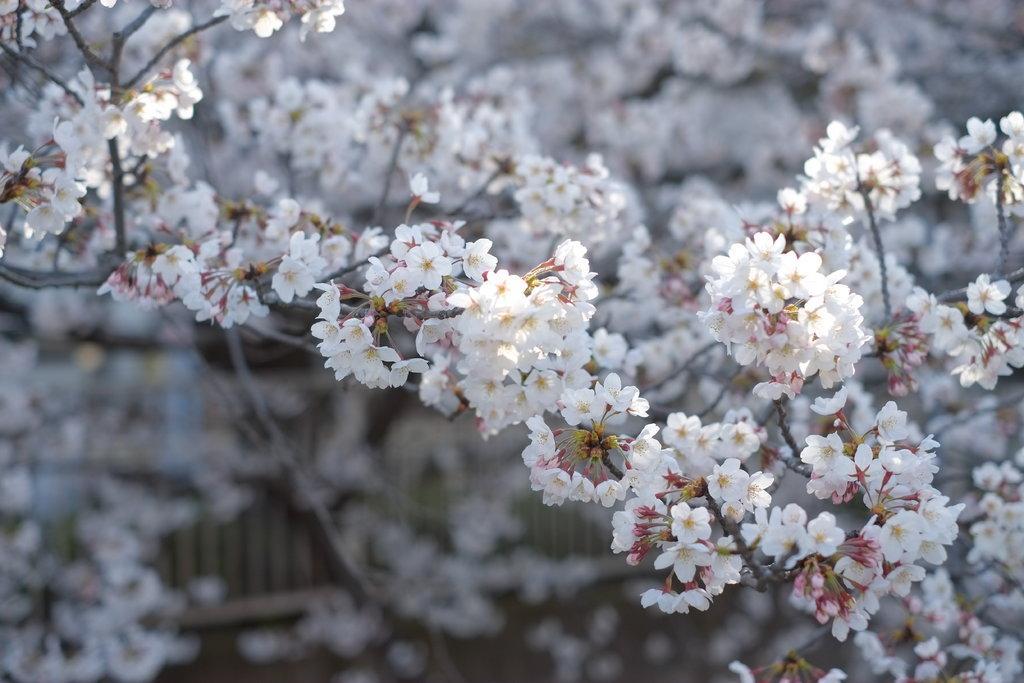Please provide a concise description of this image. In this picture there are white color flowers on the tree. At the back there is a railing. At the bottom it looks like ground. 